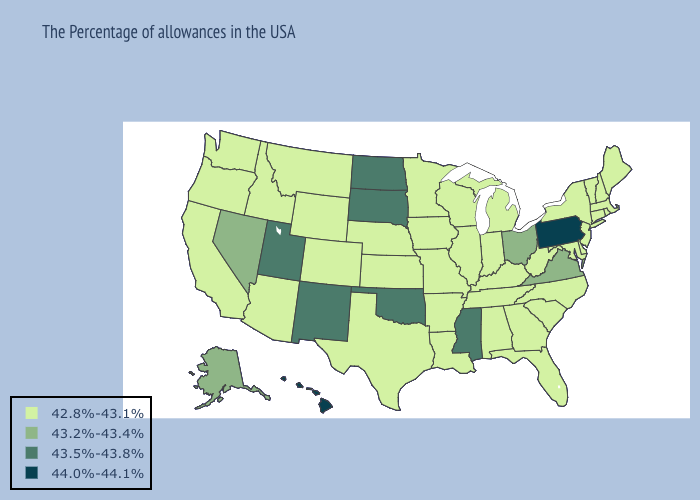Which states hav the highest value in the Northeast?
Short answer required. Pennsylvania. Does Alaska have a lower value than Utah?
Give a very brief answer. Yes. Does Maine have the same value as Oklahoma?
Short answer required. No. What is the lowest value in the West?
Short answer required. 42.8%-43.1%. Which states have the highest value in the USA?
Give a very brief answer. Pennsylvania, Hawaii. What is the highest value in states that border North Dakota?
Give a very brief answer. 43.5%-43.8%. What is the highest value in the South ?
Answer briefly. 43.5%-43.8%. Does California have the lowest value in the West?
Quick response, please. Yes. What is the value of Idaho?
Quick response, please. 42.8%-43.1%. What is the value of Rhode Island?
Write a very short answer. 42.8%-43.1%. What is the value of South Dakota?
Concise answer only. 43.5%-43.8%. Name the states that have a value in the range 43.2%-43.4%?
Short answer required. Virginia, Ohio, Nevada, Alaska. How many symbols are there in the legend?
Short answer required. 4. What is the value of Montana?
Keep it brief. 42.8%-43.1%. Which states have the highest value in the USA?
Write a very short answer. Pennsylvania, Hawaii. 